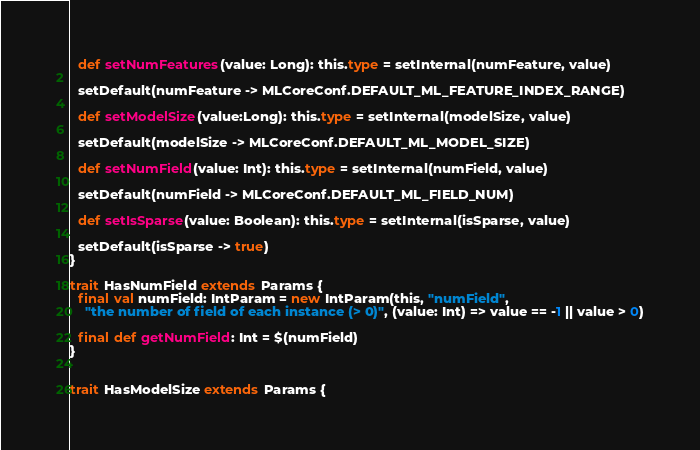Convert code to text. <code><loc_0><loc_0><loc_500><loc_500><_Scala_>
  def setNumFeatures(value: Long): this.type = setInternal(numFeature, value)

  setDefault(numFeature -> MLCoreConf.DEFAULT_ML_FEATURE_INDEX_RANGE)

  def setModelSize(value:Long): this.type = setInternal(modelSize, value)

  setDefault(modelSize -> MLCoreConf.DEFAULT_ML_MODEL_SIZE)

  def setNumField(value: Int): this.type = setInternal(numField, value)

  setDefault(numField -> MLCoreConf.DEFAULT_ML_FIELD_NUM)

  def setIsSparse(value: Boolean): this.type = setInternal(isSparse, value)

  setDefault(isSparse -> true)
}

trait HasNumField extends Params {
  final val numField: IntParam = new IntParam(this, "numField",
    "the number of field of each instance (> 0)", (value: Int) => value == -1 || value > 0)

  final def getNumField: Int = $(numField)
}


trait HasModelSize extends Params {</code> 